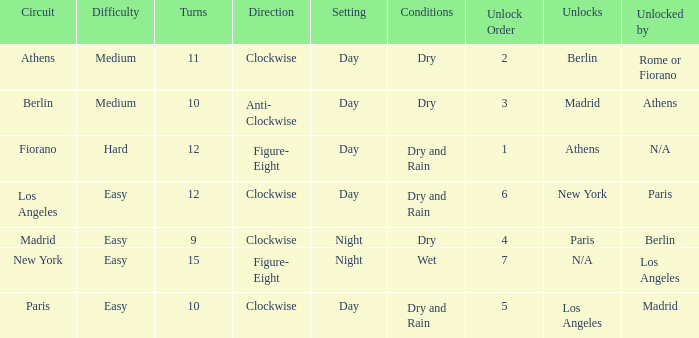What is the difficulty of the athens circuit? Medium. 